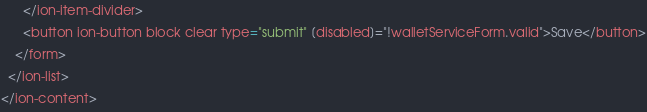Convert code to text. <code><loc_0><loc_0><loc_500><loc_500><_HTML_>      </ion-item-divider>
      <button ion-button block clear type="submit" [disabled]="!walletServiceForm.valid">Save</button>
    </form>
  </ion-list>
</ion-content>
</code> 